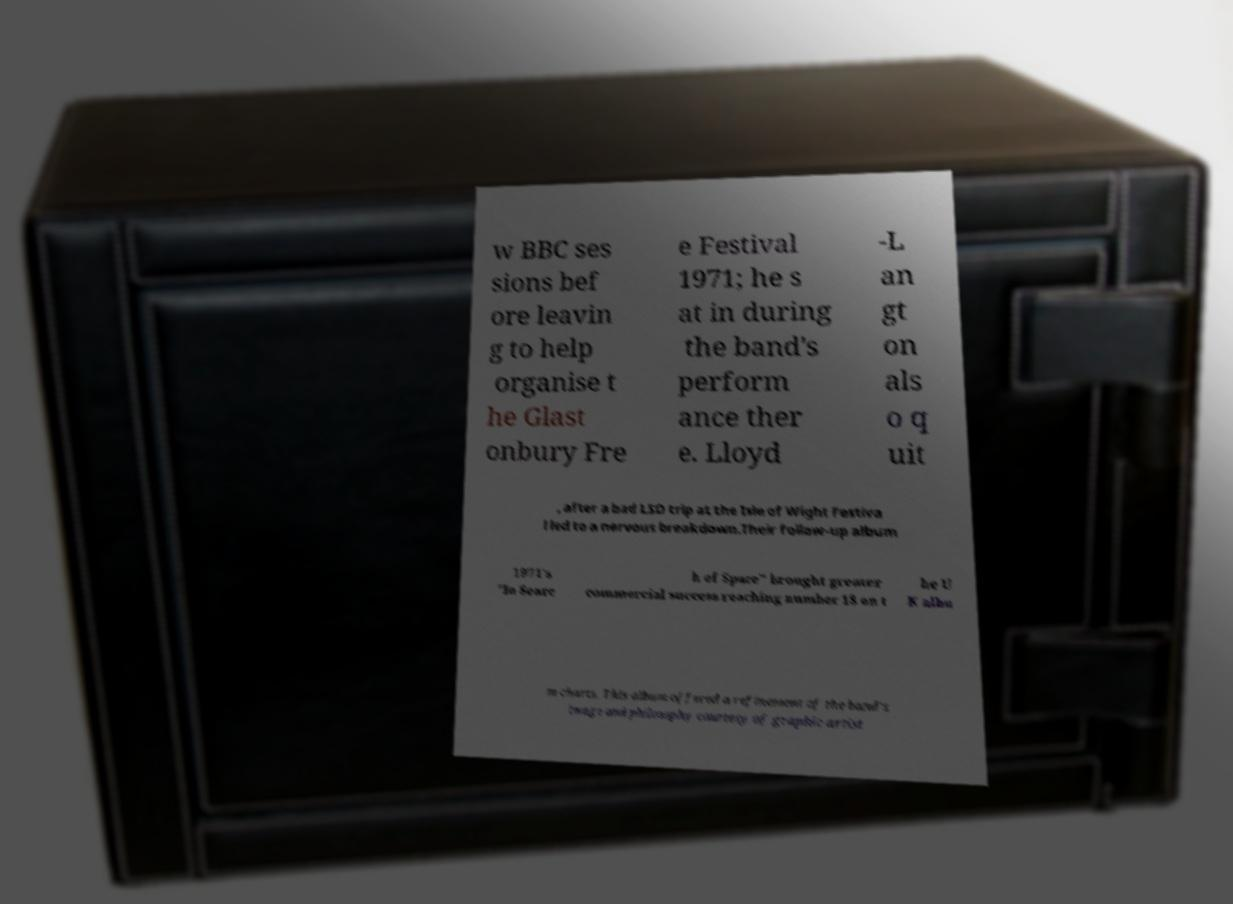Please identify and transcribe the text found in this image. w BBC ses sions bef ore leavin g to help organise t he Glast onbury Fre e Festival 1971; he s at in during the band's perform ance ther e. Lloyd -L an gt on als o q uit , after a bad LSD trip at the Isle of Wight Festiva l led to a nervous breakdown.Their follow-up album 1971's "In Searc h of Space" brought greater commercial success reaching number 18 on t he U K albu m charts. This album offered a refinement of the band's image and philosophy courtesy of graphic artist 